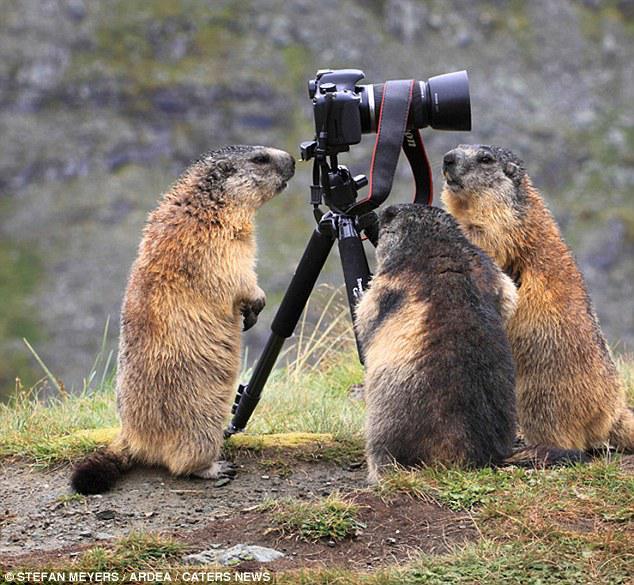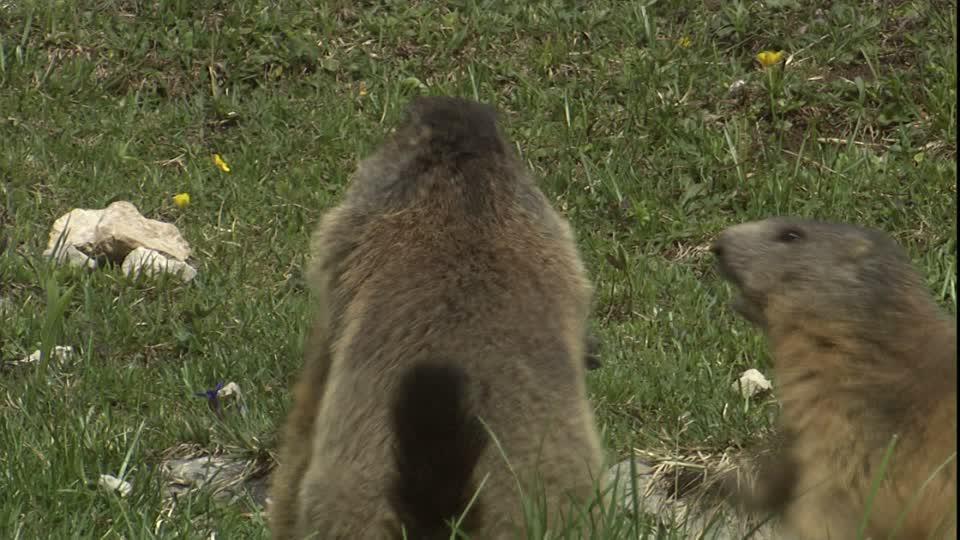The first image is the image on the left, the second image is the image on the right. Considering the images on both sides, is "The left image contains 3 marmots, and the right image contains 2 marmots." valid? Answer yes or no. Yes. The first image is the image on the left, the second image is the image on the right. Given the left and right images, does the statement "There are more animals in the image on the left." hold true? Answer yes or no. Yes. 